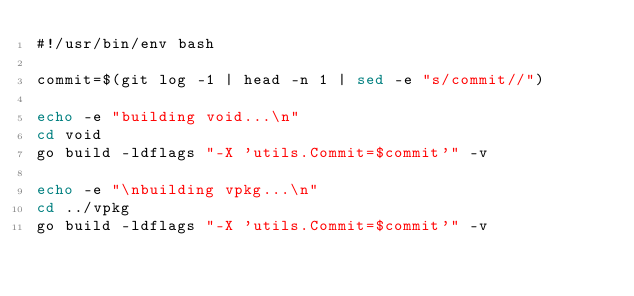<code> <loc_0><loc_0><loc_500><loc_500><_Bash_>#!/usr/bin/env bash

commit=$(git log -1 | head -n 1 | sed -e "s/commit//")

echo -e "building void...\n"
cd void
go build -ldflags "-X 'utils.Commit=$commit'" -v

echo -e "\nbuilding vpkg...\n"
cd ../vpkg
go build -ldflags "-X 'utils.Commit=$commit'" -v</code> 